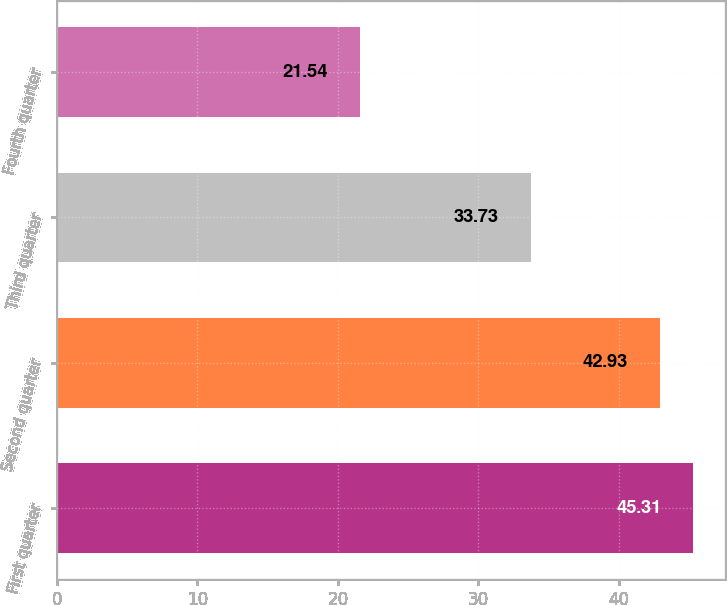Convert chart to OTSL. <chart><loc_0><loc_0><loc_500><loc_500><bar_chart><fcel>First quarter<fcel>Second quarter<fcel>Third quarter<fcel>Fourth quarter<nl><fcel>45.31<fcel>42.93<fcel>33.73<fcel>21.54<nl></chart> 